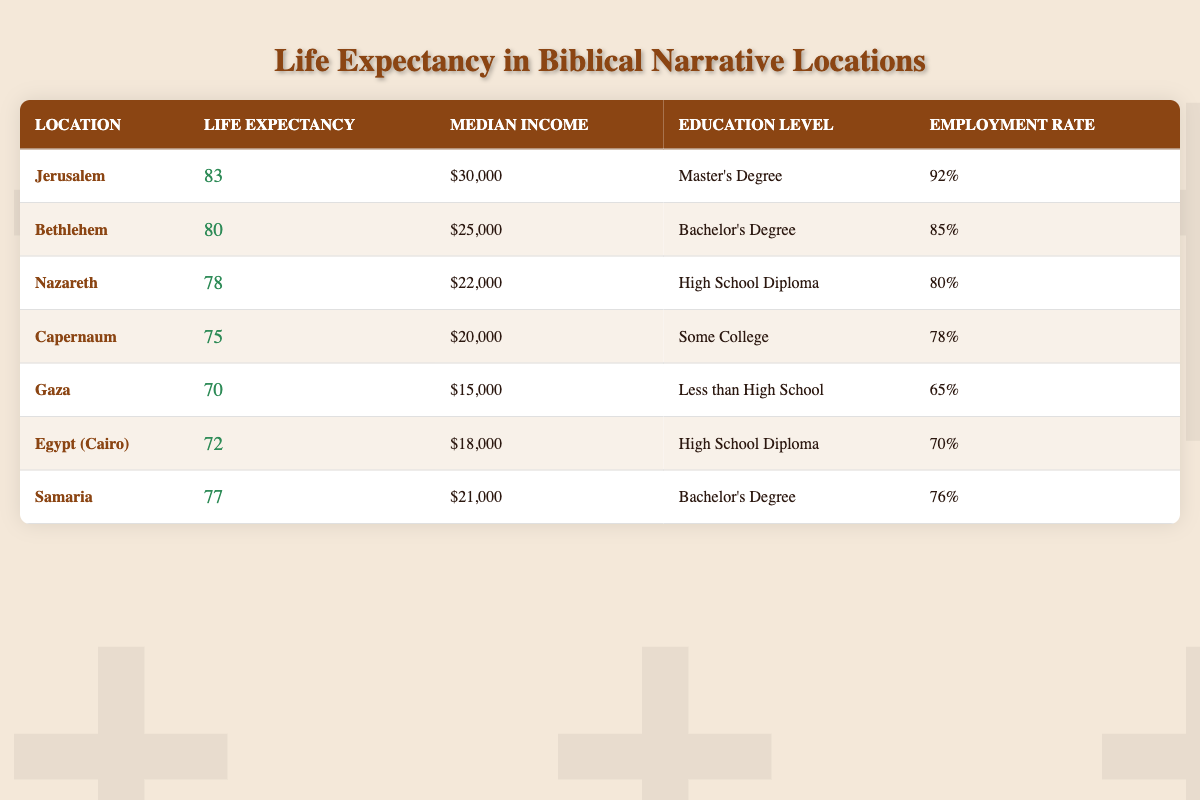What is the mean life expectancy in Jerusalem? The table indicates that the mean life expectancy in Jerusalem is listed directly and can be found in the "Life Expectancy" column for that location.
Answer: 83 Which location has the highest median income? By comparing the "Median Income" column values, Jerusalem has the highest median income at $30,000, as indicated in the respective row.
Answer: Jerusalem Is the employment rate in Gaza higher than in Nazareth? Looking at the "Employment Rate" column, Gaza has an employment rate of 65%, while Nazareth's rate is 80%. Since 65 is less than 80, the statement is false.
Answer: No What is the difference in life expectancy between Bethlehem and Capernaum? The life expectancy in Bethlehem is 80 years and in Capernaum it is 75 years. The difference can be calculated by subtracting Capernaum's life expectancy from Bethlehem's, which is 80 - 75 = 5.
Answer: 5 What is the average life expectancy of the locations listed? To find the average, sum the mean life expectancies of each location: 83 + 80 + 78 + 75 + 70 + 72 + 77 = 535. Then divide by the number of locations (7): 535 / 7 = 76.43.
Answer: 76.43 Does Samaria have a higher mean life expectancy than Gaza? By checking the "Life Expectancy" values, Samaria's life expectancy is 77 years, while Gaza's is 70 years. Since 77 is greater than 70, the statement is true.
Answer: Yes What percentage of employment is found in Egypt (Cairo)? The table shows that the employment rate for Egypt (Cairo) is 70%, which can be found directly in the "Employment Rate" column for that location.
Answer: 70 Which two locations have the same educational attainment level and what is it? By reviewing the "Education Level" column, both Bethlehem and Samaria have individuals with a "Bachelor's Degree." This similarity can be confirmed by comparing both rows.
Answer: Bethlehem and Samaria; Bachelor's Degree What is the median income of the location with the lowest life expectancy? The location with the lowest life expectancy is Gaza at 70 years, and its median income listed in the table is $15,000, found in the corresponding row.
Answer: 15,000 